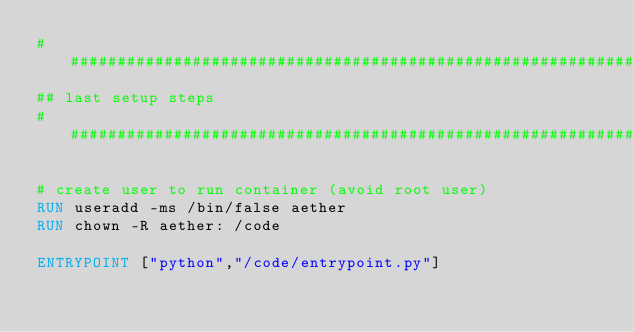<code> <loc_0><loc_0><loc_500><loc_500><_Dockerfile_>################################################################################
## last setup steps
################################################################################

# create user to run container (avoid root user)
RUN useradd -ms /bin/false aether
RUN chown -R aether: /code

ENTRYPOINT ["python","/code/entrypoint.py"]</code> 